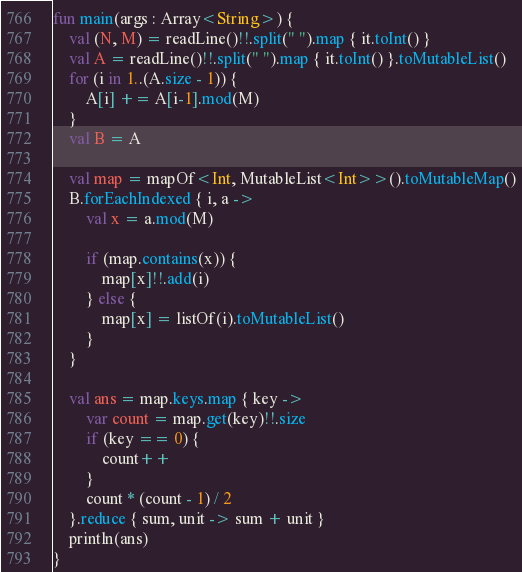Convert code to text. <code><loc_0><loc_0><loc_500><loc_500><_Kotlin_>
fun main(args : Array<String>) {
    val (N, M) = readLine()!!.split(" ").map { it.toInt() }
    val A = readLine()!!.split(" ").map { it.toInt() }.toMutableList()
    for (i in 1..(A.size - 1)) {
        A[i] += A[i-1].mod(M)
    }
    val B = A

    val map = mapOf<Int, MutableList<Int>>().toMutableMap()
    B.forEachIndexed { i, a ->
        val x = a.mod(M)

        if (map.contains(x)) {
            map[x]!!.add(i)
        } else {
            map[x] = listOf(i).toMutableList()
        }
    }

    val ans = map.keys.map { key ->
        var count = map.get(key)!!.size
        if (key == 0) {
            count++
        }
        count * (count - 1) / 2
    }.reduce { sum, unit -> sum + unit }
    println(ans)
}</code> 